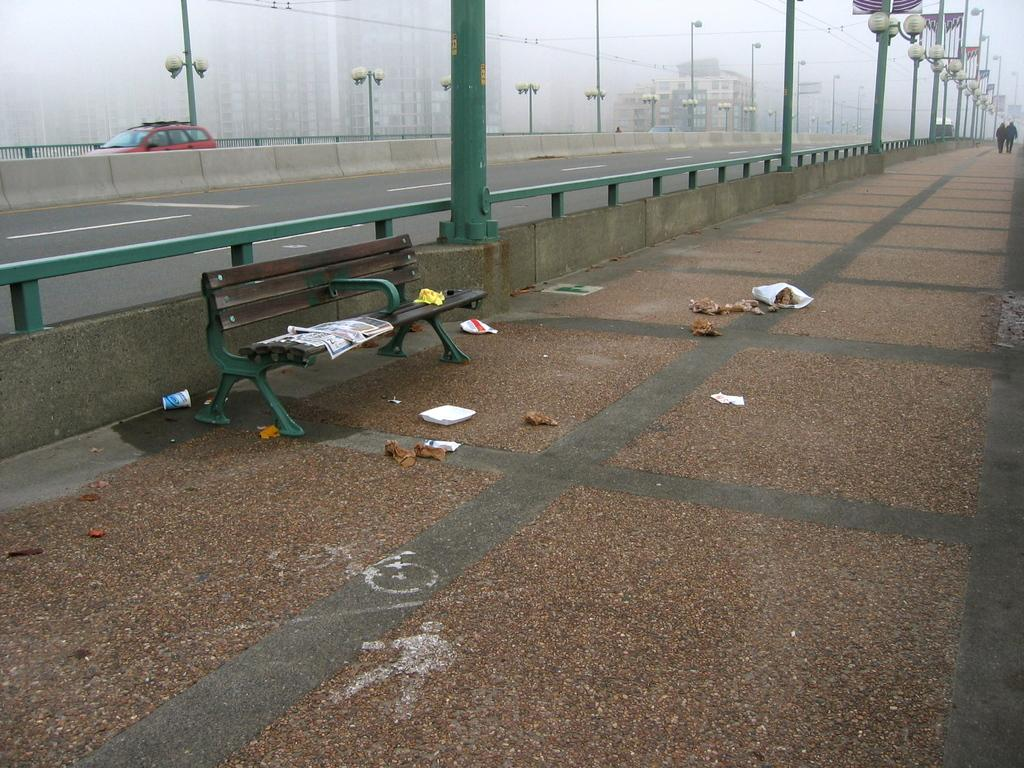What can be seen running through the image? There is a path in the image. What is available for people to sit on in the image? There is a bench in the image. What is present on the path in the image? There are objects on the path. Can you describe the people in the image? There are people in the image. What structures are present in the image? There are poles in the image. What mode of transportation is visible in the image? There is a vehicle in the image. What type of man-made structures can be seen in the image? There are buildings in the image. What else is present in the image besides the path, bench, objects, people, poles, vehicle, and buildings? There are wires in the image. What type of bat is flying over the buildings in the image? There is no bat present in the image; it only features a path, bench, objects, people, poles, vehicle, buildings, and wires. 